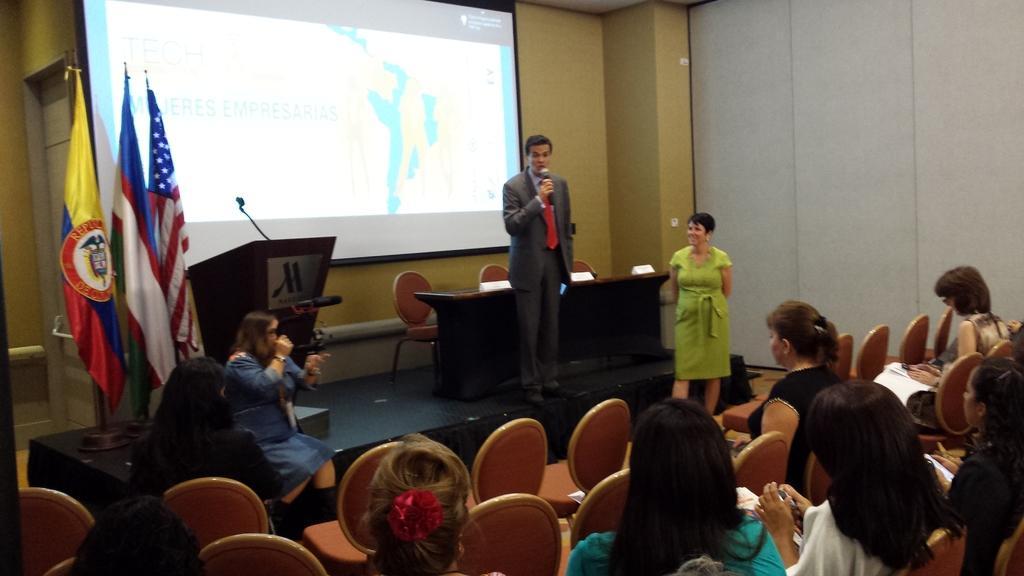Can you describe this image briefly? Here we can see that a man is standing on the stage and holding a microphone in his hands, and at back there is the table, and here is the woman, and here is the flag, and here the group of people are sitting on the chair, and here is the projector, attached to wall. 